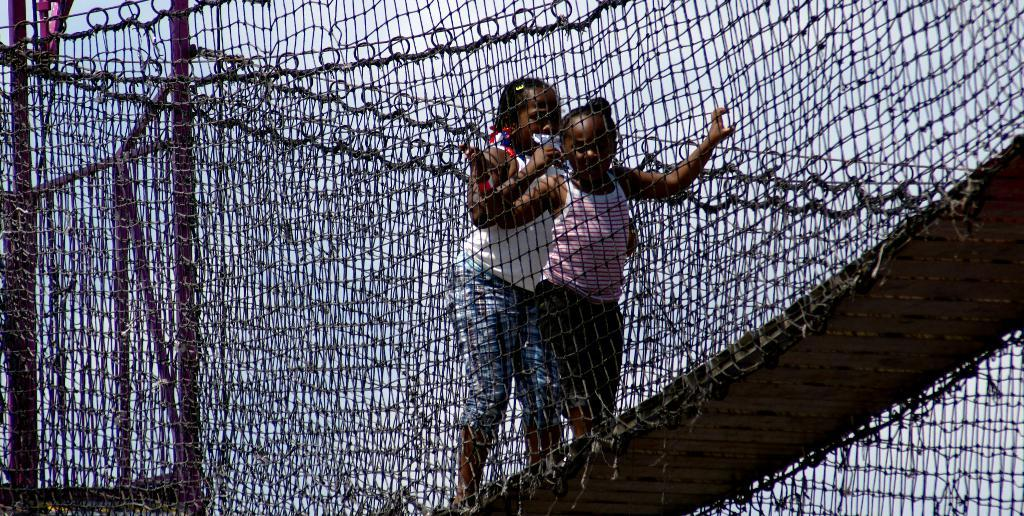How many girls are in the image? There are two girls in the image. What are the girls standing on? The girls are standing on an object that resembles a bridge. What are the girls holding? The girls are holding a fence. What other objects can be seen in the image? There are poles in the image. What is visible in the background of the image? The sky is visible in the image. What type of glove is the girl wearing on her left hand? There is no glove visible on the girl's left hand in the image. What type of skirt is the girl wearing? There is no skirt visible on the girl in the image. 